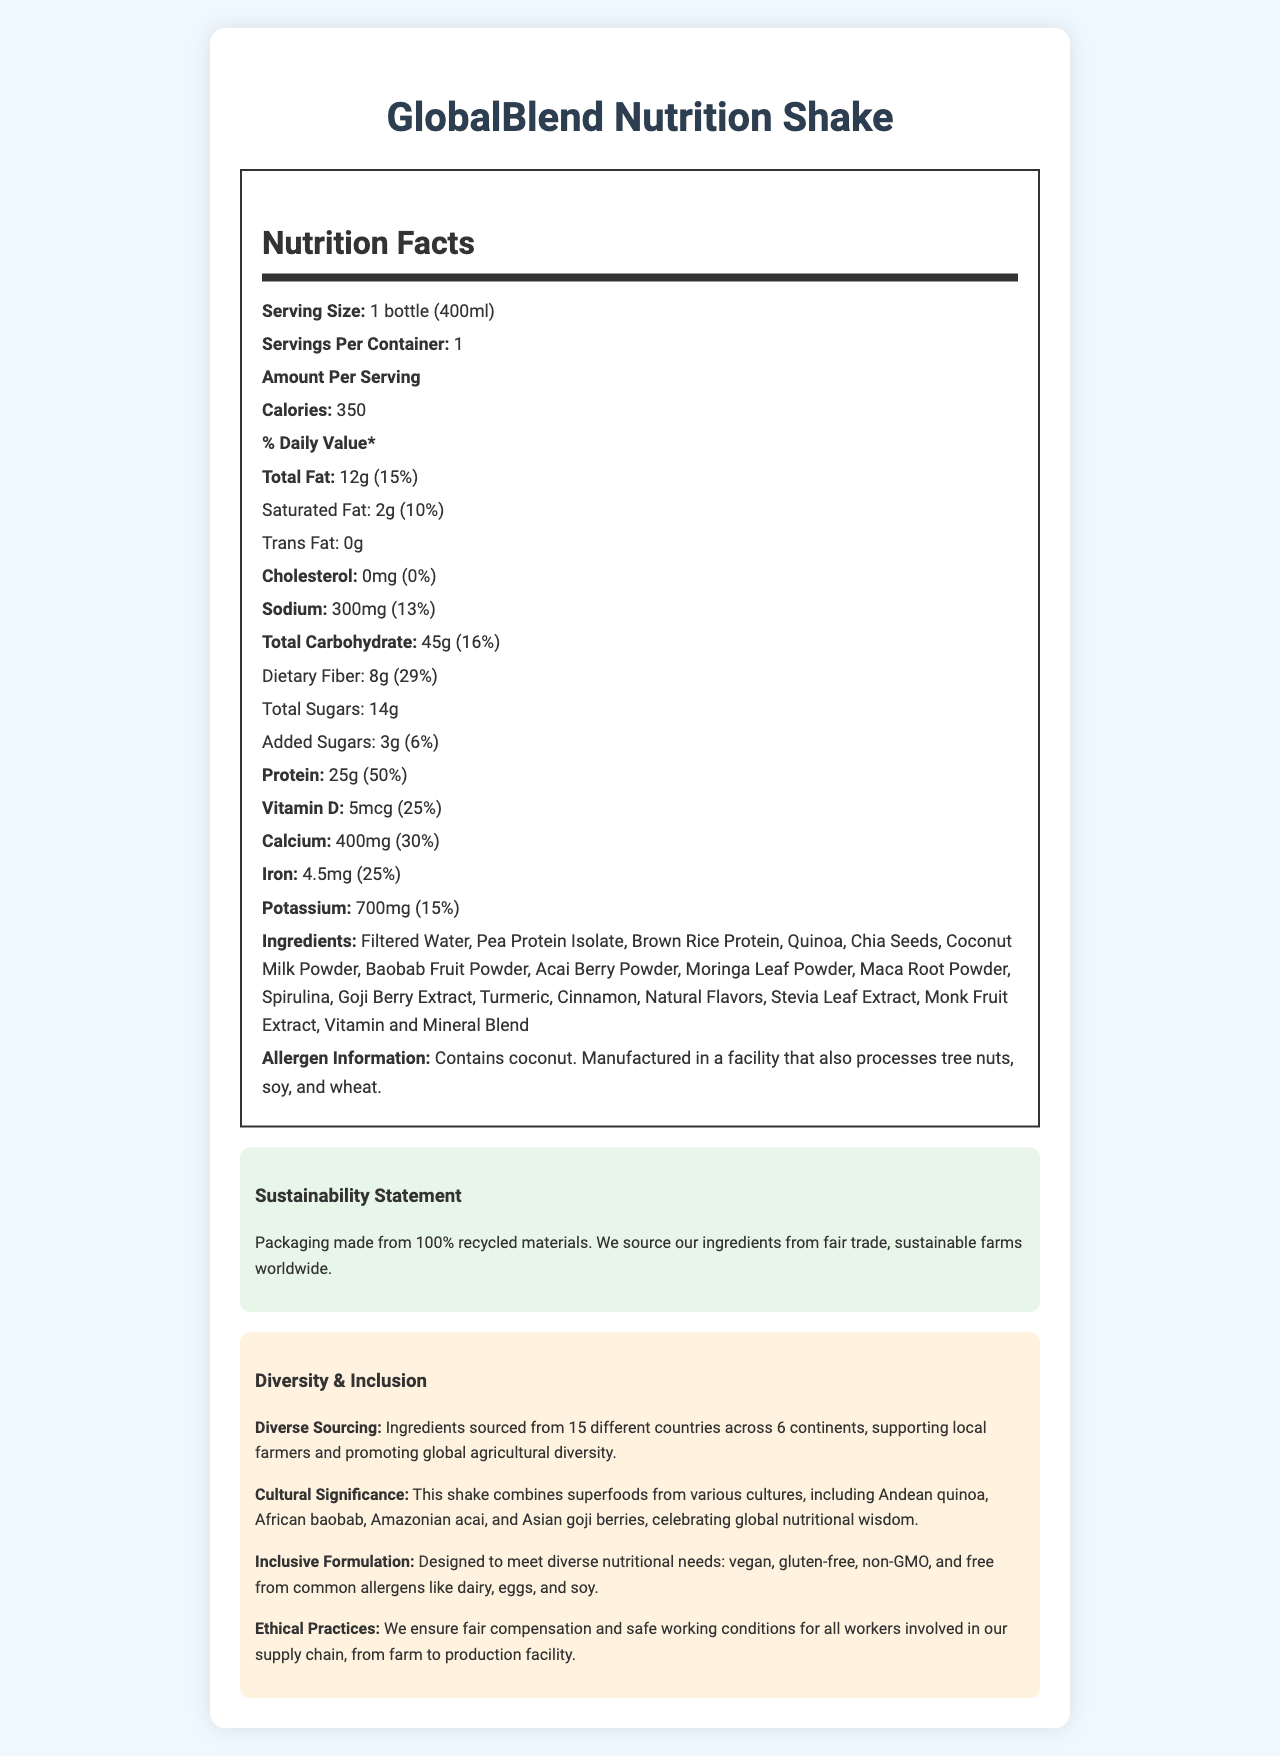what is the serving size of the GlobalBlend Nutrition Shake? The serving size is clearly stated in the document as "1 bottle (400ml)".
Answer: 1 bottle (400ml) what is the amount of dietary fiber per serving? The document lists the dietary fiber content under the "Total Carbohydrate" section as 8g.
Answer: 8g what is the daily value percentage for calcium? The daily value percentage for calcium is listed as 30% in the document.
Answer: 30% does the shake contain any cholesterol? The cholesterol content is listed as 0mg with a daily value of 0%.
Answer: No provide an example of an ingredient sourced from the Andean region. The document lists quinoa as one of the ingredients, specifically noting its cultural significance from the Andean region.
Answer: Quinoa what type of protein is included in the GlobalBlend Nutrition Shake? A. Whey Protein B. Soy Protein C. Pea Protein D. Hemp Protein The document lists "Pea Protein Isolate" as one of the ingredients.
Answer: C. Pea Protein which vitamin has the highest daily value percentage? A. Vitamin A B. Vitamin D C. Vitamin B12 D. Vitamin C Vitamin B12 has a daily value percentage of 100%, which is higher than the other listed vitamins.
Answer: C. Vitamin B12 does the GlobalBlend Nutrition Shake contain any added sugars? The document indicates that the shake contains "3g" of added sugars.
Answer: Yes summarize the sustainability statement of the GlobalBlend Nutrition Shake. The sustainability statement highlights the use of 100% recycled materials for packaging and sourcing ingredients from fair trade, sustainable farms globally.
Answer: Packaging made from 100% recycled materials. We source our ingredients from fair trade, sustainable farms worldwide. is the GlobalBlend Nutrition Shake gluten-free? The inclusive formulation section mentions that the shake is gluten-free.
Answer: Yes what is the price of the GlobalBlend Nutrition Shake? The document does not provide any information about the price of the shake.
Answer: Not enough information how many different countries are represented in the ingredient sourcing? The document states that the ingredients are sourced from 15 different countries across 6 continents.
Answer: 15 what is the total carbohydrate content per serving? The total carbohydrate content is listed as 45g per serving in the document.
Answer: 45g what is the allergen information for the product? The document lists the allergen information under a dedicated section, stating the product contains coconut and is manufactured in a facility that processes tree nuts, soy, and wheat.
Answer: Contains coconut. Manufactured in a facility that also processes tree nuts, soy, and wheat. what percentage of the daily value for magnesium is provided by the shake? The document specifies that the shake provides 33% of the daily value for magnesium.
Answer: 33% 